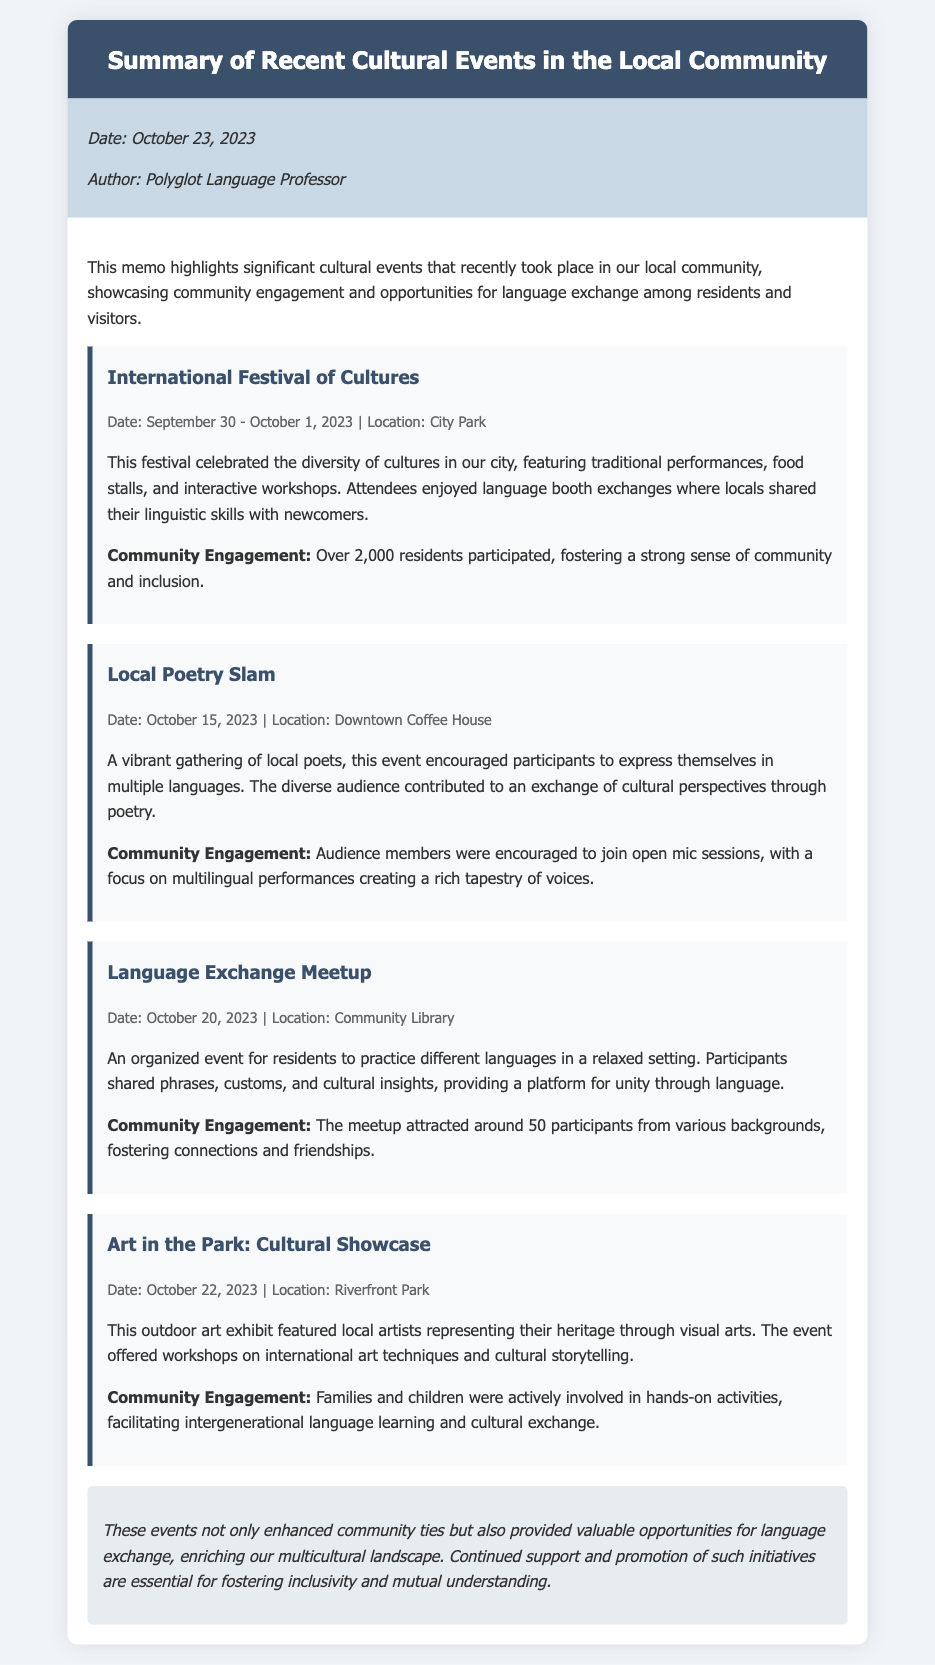What was the date of the International Festival of Cultures? This event took place over two days, September 30 to October 1, 2023.
Answer: September 30 - October 1, 2023 Where was the Local Poetry Slam held? The event took place at a specific location mentioned, the Downtown Coffee House.
Answer: Downtown Coffee House How many participants attended the Language Exchange Meetup? The memo states that around 50 participants were present at this event.
Answer: 50 What kind of activities were featured at the Art in the Park event? The memo talks about workshops on international art techniques and cultural storytelling as part of this event.
Answer: Workshops on international art techniques and cultural storytelling What is the primary theme of the memo? The memo summarizes significant cultural events focusing on community engagement and opportunities for language exchange.
Answer: Summary of Recent Cultural Events What significant participation figure was associated with the International Festival of Cultures? Over 2,000 residents participated, indicating a strong community engagement for this event.
Answer: Over 2,000 residents What was the date of the Language Exchange Meetup? The memo specifies that this event took place on October 20, 2023.
Answer: October 20, 2023 Which event highlighted the representation of local artists' heritage? This is explicitly stated as the Art in the Park: Cultural Showcase, which featured local artists.
Answer: Art in the Park: Cultural Showcase 